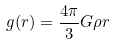Convert formula to latex. <formula><loc_0><loc_0><loc_500><loc_500>g ( r ) = \frac { 4 \pi } { 3 } G \rho r</formula> 